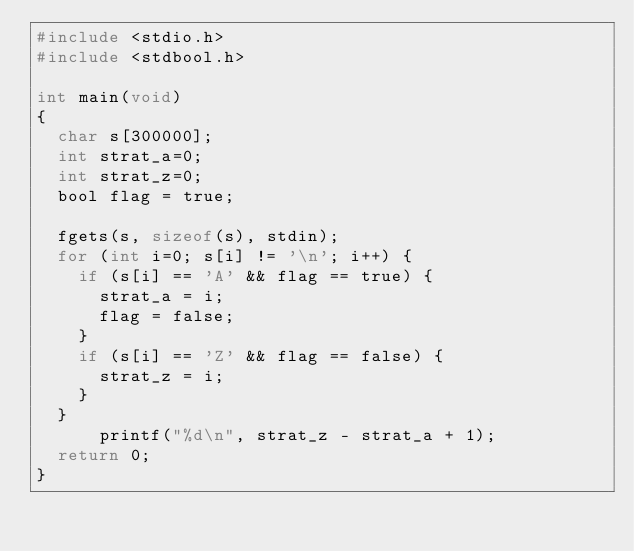Convert code to text. <code><loc_0><loc_0><loc_500><loc_500><_C_>#include <stdio.h>
#include <stdbool.h>

int main(void)
{
  char s[300000];
  int strat_a=0;
  int strat_z=0;
  bool flag = true;

  fgets(s, sizeof(s), stdin);
  for (int i=0; s[i] != '\n'; i++) {
    if (s[i] == 'A' && flag == true) {
      strat_a = i;
      flag = false;
    }
    if (s[i] == 'Z' && flag == false) {
      strat_z = i;
    }
  }
      printf("%d\n", strat_z - strat_a + 1);
  return 0;
}
</code> 